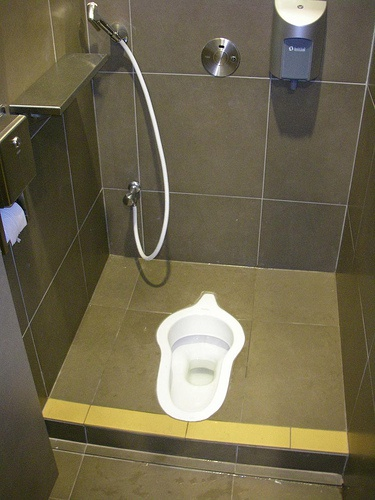Describe the objects in this image and their specific colors. I can see a toilet in darkgreen, ivory, darkgray, beige, and tan tones in this image. 